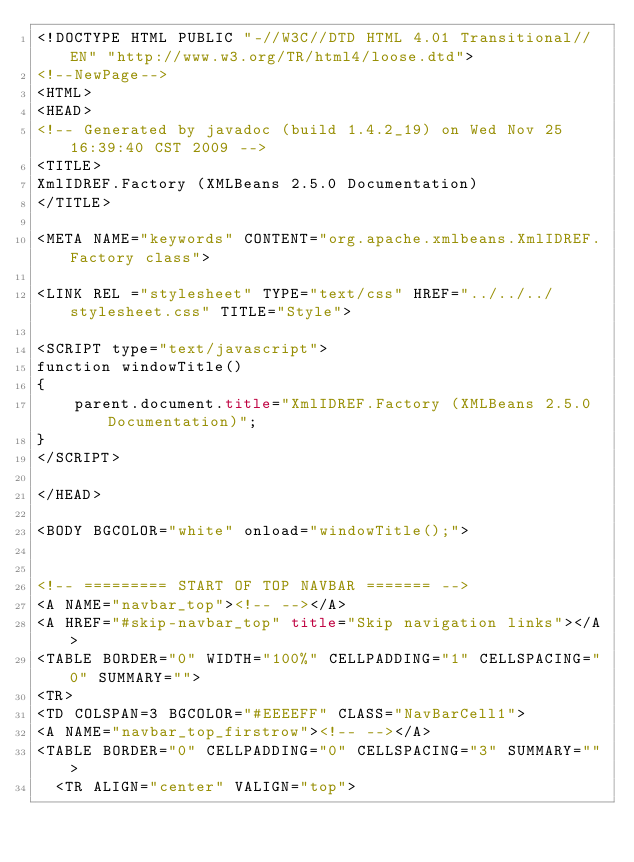Convert code to text. <code><loc_0><loc_0><loc_500><loc_500><_HTML_><!DOCTYPE HTML PUBLIC "-//W3C//DTD HTML 4.01 Transitional//EN" "http://www.w3.org/TR/html4/loose.dtd">
<!--NewPage-->
<HTML>
<HEAD>
<!-- Generated by javadoc (build 1.4.2_19) on Wed Nov 25 16:39:40 CST 2009 -->
<TITLE>
XmlIDREF.Factory (XMLBeans 2.5.0 Documentation)
</TITLE>

<META NAME="keywords" CONTENT="org.apache.xmlbeans.XmlIDREF.Factory class">

<LINK REL ="stylesheet" TYPE="text/css" HREF="../../../stylesheet.css" TITLE="Style">

<SCRIPT type="text/javascript">
function windowTitle()
{
    parent.document.title="XmlIDREF.Factory (XMLBeans 2.5.0 Documentation)";
}
</SCRIPT>

</HEAD>

<BODY BGCOLOR="white" onload="windowTitle();">


<!-- ========= START OF TOP NAVBAR ======= -->
<A NAME="navbar_top"><!-- --></A>
<A HREF="#skip-navbar_top" title="Skip navigation links"></A>
<TABLE BORDER="0" WIDTH="100%" CELLPADDING="1" CELLSPACING="0" SUMMARY="">
<TR>
<TD COLSPAN=3 BGCOLOR="#EEEEFF" CLASS="NavBarCell1">
<A NAME="navbar_top_firstrow"><!-- --></A>
<TABLE BORDER="0" CELLPADDING="0" CELLSPACING="3" SUMMARY="">
  <TR ALIGN="center" VALIGN="top"></code> 